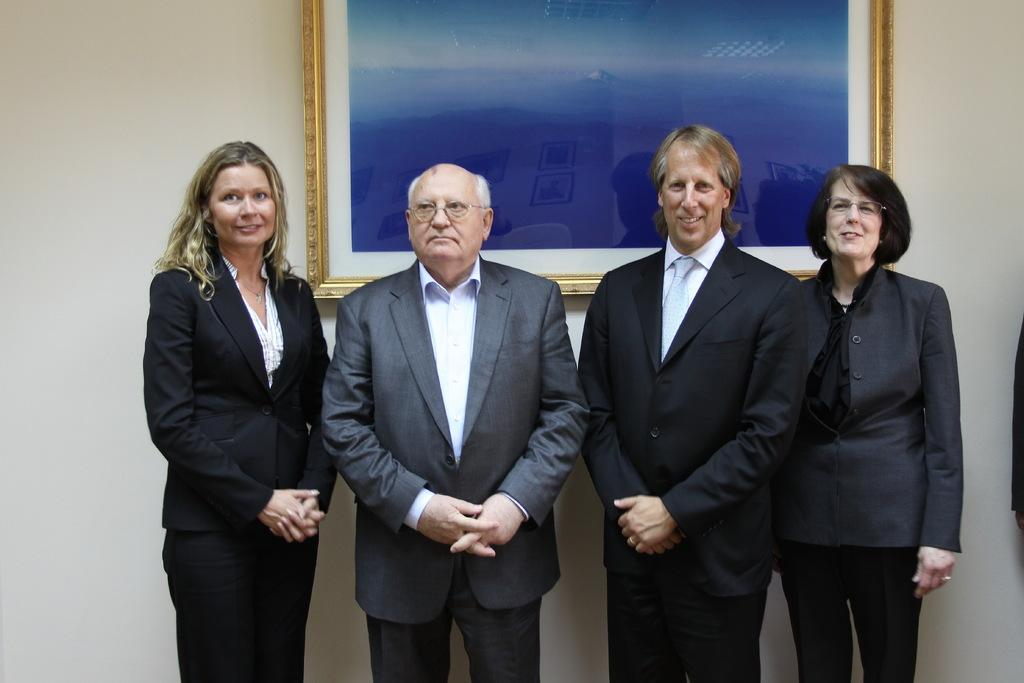What can be seen in the image? There is a group of men in the image. What are the men doing in the image? The men are standing in the image. What are the men wearing in the image? The men are wearing suits in the image. What can be seen in the background of the image? There is a photo on the wall in the background of the image. What type of hen can be seen perched on the shoulder of one of the men in the image? There is no hen present in the image; it only features a group of men standing and wearing suits. 